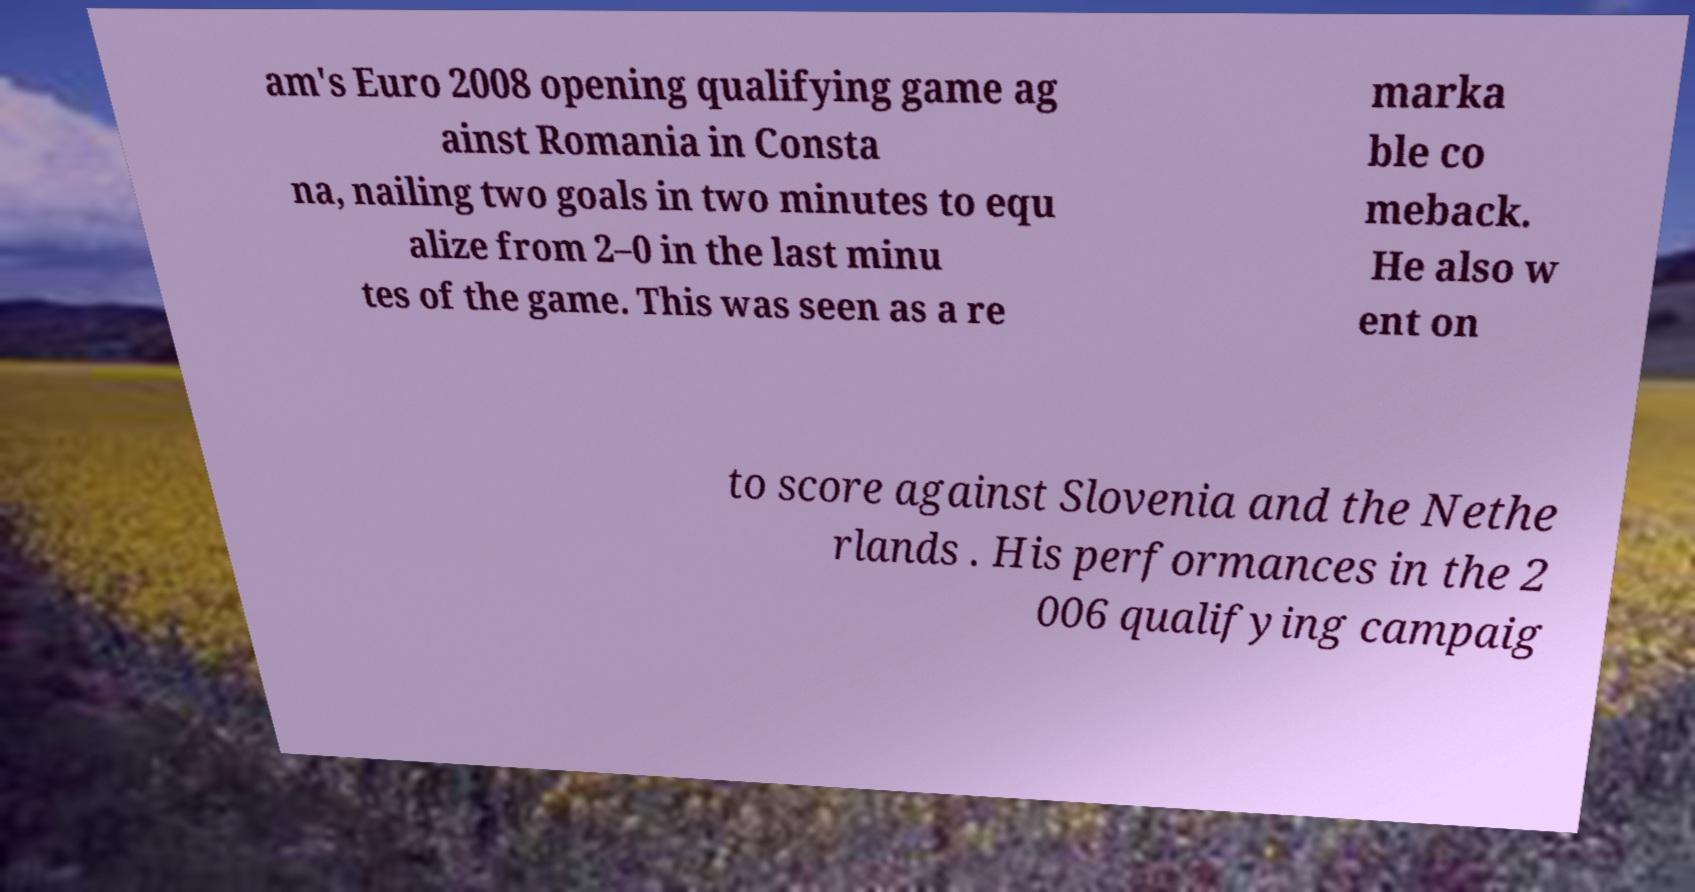What messages or text are displayed in this image? I need them in a readable, typed format. am's Euro 2008 opening qualifying game ag ainst Romania in Consta na, nailing two goals in two minutes to equ alize from 2–0 in the last minu tes of the game. This was seen as a re marka ble co meback. He also w ent on to score against Slovenia and the Nethe rlands . His performances in the 2 006 qualifying campaig 